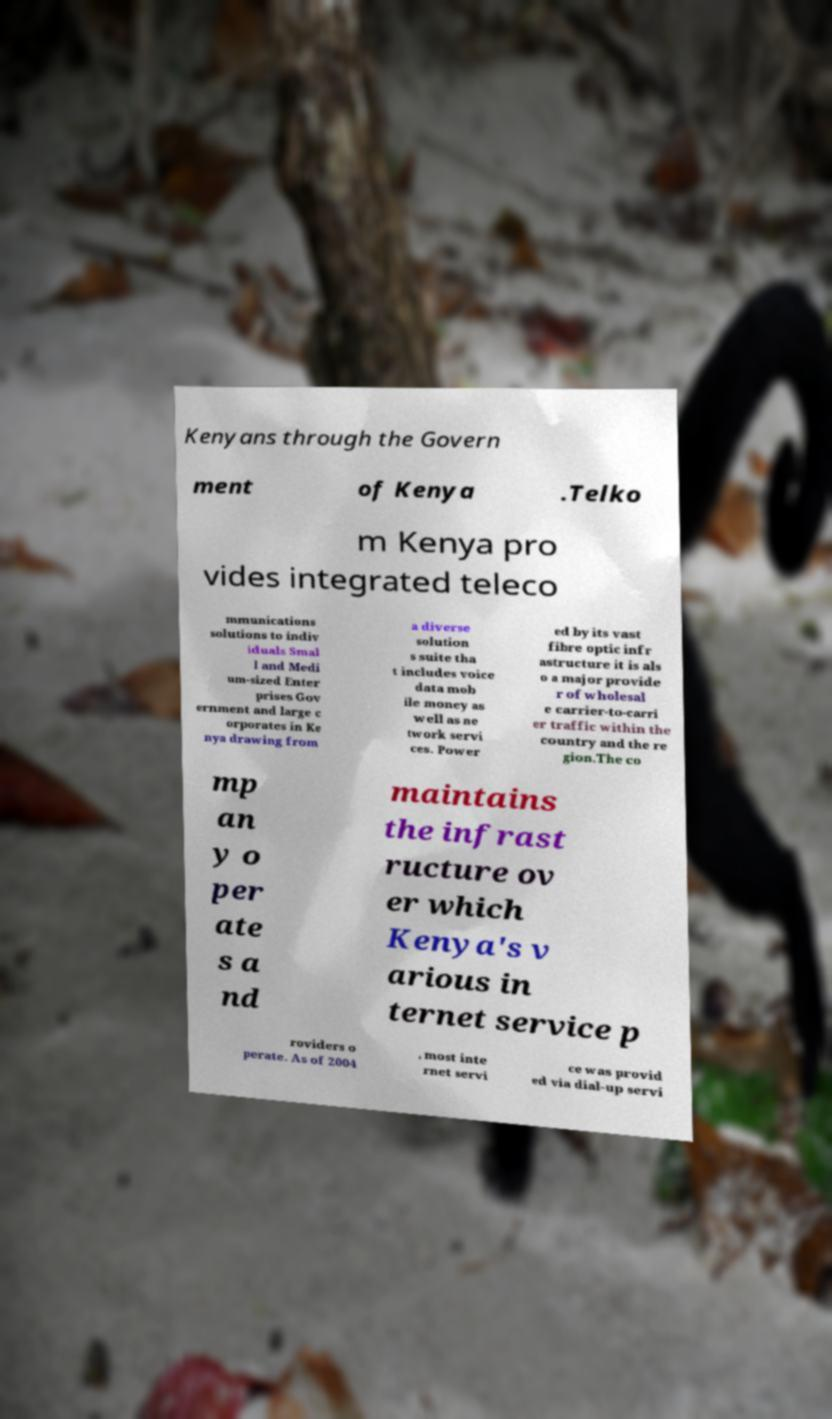Please identify and transcribe the text found in this image. Kenyans through the Govern ment of Kenya .Telko m Kenya pro vides integrated teleco mmunications solutions to indiv iduals Smal l and Medi um-sized Enter prises Gov ernment and large c orporates in Ke nya drawing from a diverse solution s suite tha t includes voice data mob ile money as well as ne twork servi ces. Power ed by its vast fibre optic infr astructure it is als o a major provide r of wholesal e carrier-to-carri er traffic within the country and the re gion.The co mp an y o per ate s a nd maintains the infrast ructure ov er which Kenya's v arious in ternet service p roviders o perate. As of 2004 , most inte rnet servi ce was provid ed via dial-up servi 